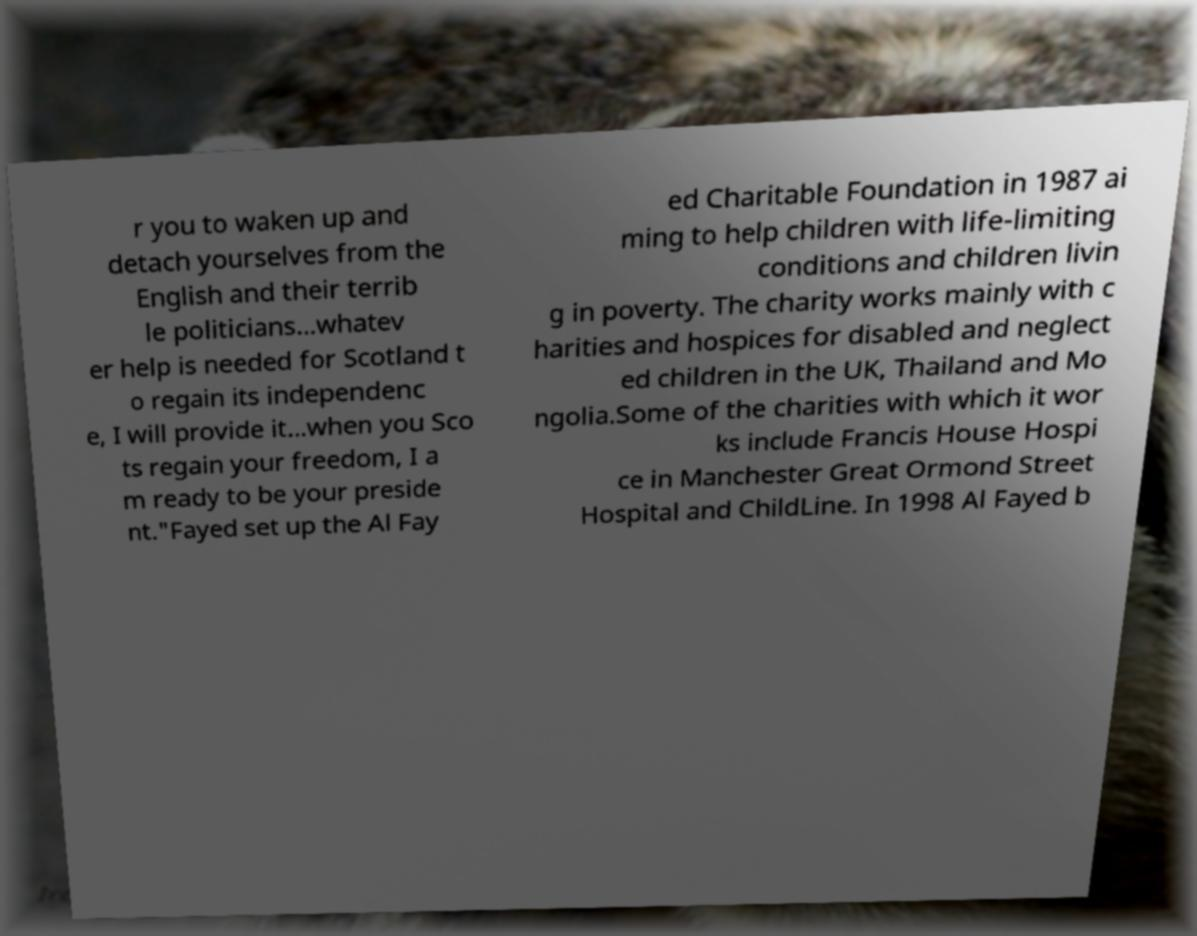Could you assist in decoding the text presented in this image and type it out clearly? r you to waken up and detach yourselves from the English and their terrib le politicians...whatev er help is needed for Scotland t o regain its independenc e, I will provide it...when you Sco ts regain your freedom, I a m ready to be your preside nt."Fayed set up the Al Fay ed Charitable Foundation in 1987 ai ming to help children with life-limiting conditions and children livin g in poverty. The charity works mainly with c harities and hospices for disabled and neglect ed children in the UK, Thailand and Mo ngolia.Some of the charities with which it wor ks include Francis House Hospi ce in Manchester Great Ormond Street Hospital and ChildLine. In 1998 Al Fayed b 